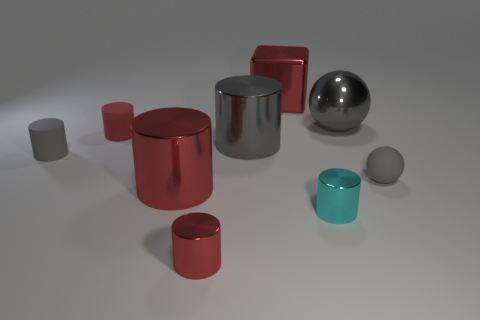Subtract all red blocks. How many red cylinders are left? 3 Subtract all cyan cylinders. How many cylinders are left? 5 Subtract 2 cylinders. How many cylinders are left? 4 Subtract all cyan metallic cylinders. How many cylinders are left? 5 Subtract all cyan cylinders. Subtract all gray blocks. How many cylinders are left? 5 Subtract all cylinders. How many objects are left? 3 Add 5 tiny objects. How many tiny objects exist? 10 Subtract 0 blue cubes. How many objects are left? 9 Subtract all big gray spheres. Subtract all small red metallic things. How many objects are left? 7 Add 8 gray shiny balls. How many gray shiny balls are left? 9 